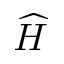<formula> <loc_0><loc_0><loc_500><loc_500>\widehat { H }</formula> 